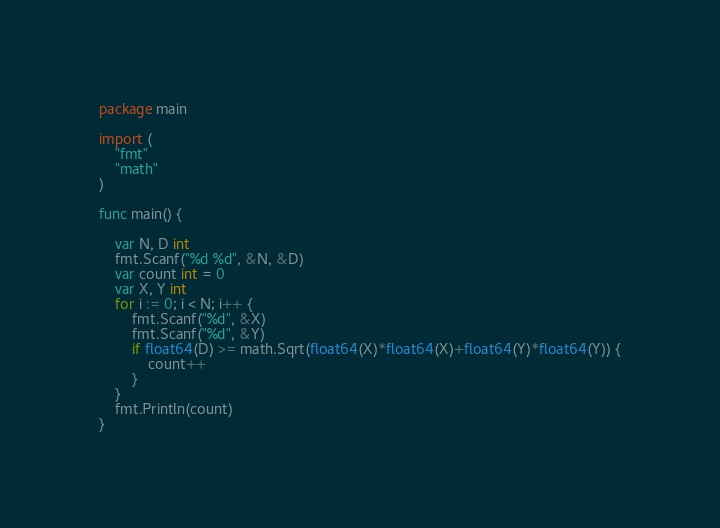Convert code to text. <code><loc_0><loc_0><loc_500><loc_500><_Go_>package main

import (
	"fmt"
	"math"
)

func main() {

	var N, D int
	fmt.Scanf("%d %d", &N, &D)
	var count int = 0
	var X, Y int
	for i := 0; i < N; i++ {
		fmt.Scanf("%d", &X)
		fmt.Scanf("%d", &Y)
		if float64(D) >= math.Sqrt(float64(X)*float64(X)+float64(Y)*float64(Y)) {
			count++
		}
	}
	fmt.Println(count)
}
</code> 